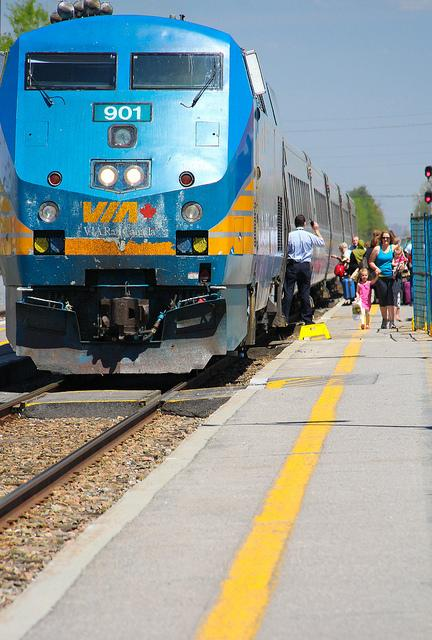What is the occupation of the man on the yellow step?

Choices:
A) waiter
B) musician
C) doctor
D) conductor conductor 